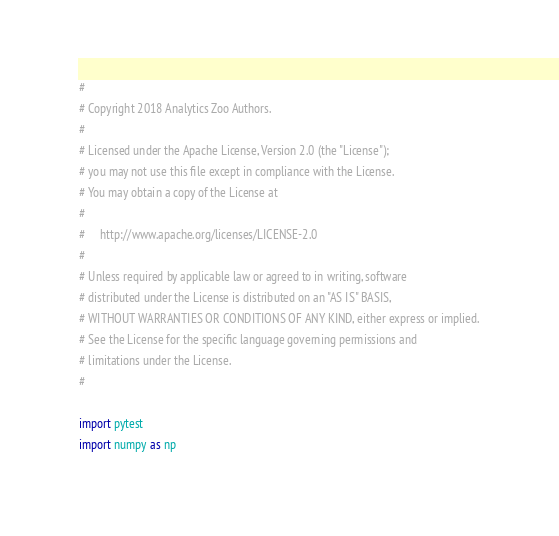<code> <loc_0><loc_0><loc_500><loc_500><_Python_>#
# Copyright 2018 Analytics Zoo Authors.
#
# Licensed under the Apache License, Version 2.0 (the "License");
# you may not use this file except in compliance with the License.
# You may obtain a copy of the License at
#
#     http://www.apache.org/licenses/LICENSE-2.0
#
# Unless required by applicable law or agreed to in writing, software
# distributed under the License is distributed on an "AS IS" BASIS,
# WITHOUT WARRANTIES OR CONDITIONS OF ANY KIND, either express or implied.
# See the License for the specific language governing permissions and
# limitations under the License.
#

import pytest
import numpy as np</code> 